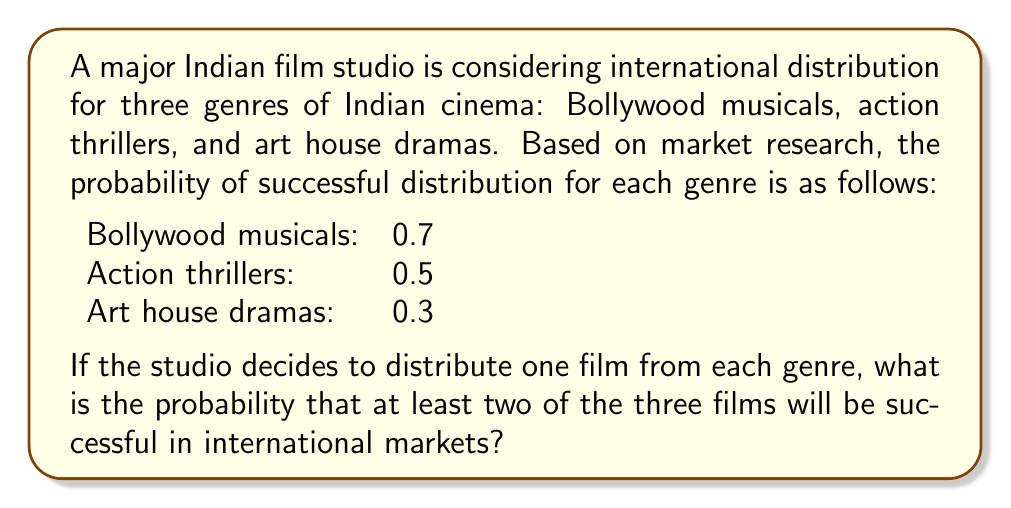Teach me how to tackle this problem. Let's approach this step-by-step using the concept of complementary events and the addition rule of probability.

Step 1: Define the event
Let A be the event that at least two of the three films are successful.

Step 2: Find the complement of A
The complement of A is the event that either no films are successful or only one film is successful.

Step 3: Calculate the probability of the complement
P(complement of A) = P(no films successful) + P(only one film successful)

P(no films successful) = (1-0.7) * (1-0.5) * (1-0.3) = 0.3 * 0.5 * 0.7 = 0.105

P(only Bollywood musical successful) = 0.7 * 0.5 * 0.7 = 0.245
P(only action thriller successful) = 0.3 * 0.5 * 0.7 = 0.105
P(only art house drama successful) = 0.3 * 0.5 * 0.3 = 0.045

P(only one film successful) = 0.245 + 0.105 + 0.045 = 0.395

P(complement of A) = 0.105 + 0.395 = 0.5

Step 4: Calculate the probability of A
P(A) = 1 - P(complement of A) = 1 - 0.5 = 0.5

Therefore, the probability that at least two of the three films will be successful in international markets is 0.5 or 50%.
Answer: 0.5 